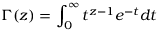<formula> <loc_0><loc_0><loc_500><loc_500>\Gamma ( z ) = \int _ { 0 } ^ { \infty } t ^ { z - 1 } e ^ { - t } d t</formula> 